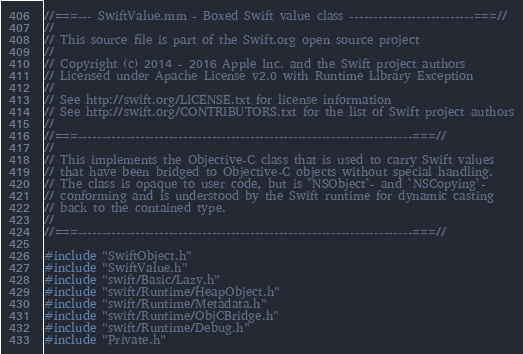<code> <loc_0><loc_0><loc_500><loc_500><_ObjectiveC_>//===--- SwiftValue.mm - Boxed Swift value class --------------------------===//
//
// This source file is part of the Swift.org open source project
//
// Copyright (c) 2014 - 2016 Apple Inc. and the Swift project authors
// Licensed under Apache License v2.0 with Runtime Library Exception
//
// See http://swift.org/LICENSE.txt for license information
// See http://swift.org/CONTRIBUTORS.txt for the list of Swift project authors
//
//===----------------------------------------------------------------------===//
//
// This implements the Objective-C class that is used to carry Swift values
// that have been bridged to Objective-C objects without special handling.
// The class is opaque to user code, but is `NSObject`- and `NSCopying`-
// conforming and is understood by the Swift runtime for dynamic casting
// back to the contained type.
//
//===----------------------------------------------------------------------===//

#include "SwiftObject.h"
#include "SwiftValue.h"
#include "swift/Basic/Lazy.h"
#include "swift/Runtime/HeapObject.h"
#include "swift/Runtime/Metadata.h"
#include "swift/Runtime/ObjCBridge.h"
#include "swift/Runtime/Debug.h"
#include "Private.h"</code> 